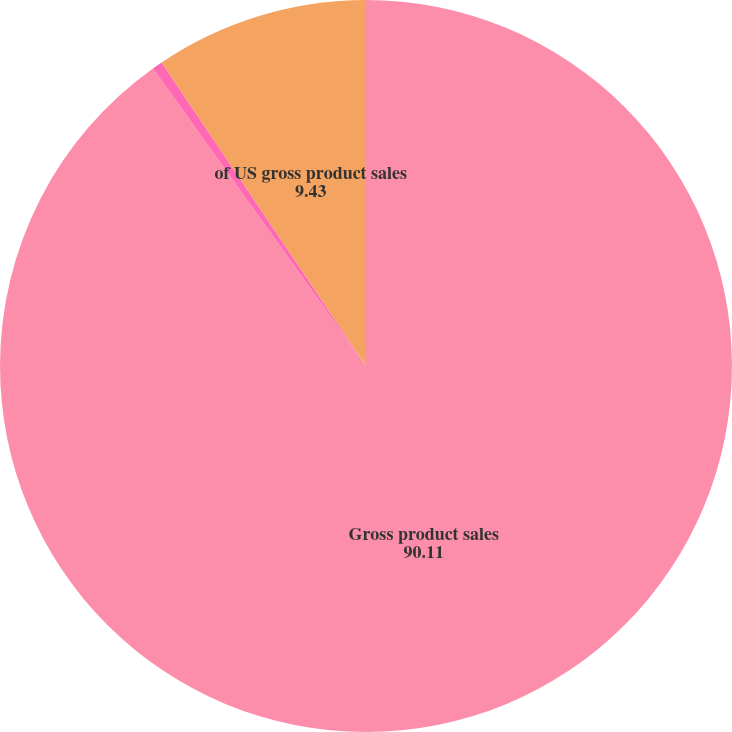Convert chart to OTSL. <chart><loc_0><loc_0><loc_500><loc_500><pie_chart><fcel>Gross product sales<fcel>of total gross revenues<fcel>of US gross product sales<nl><fcel>90.11%<fcel>0.46%<fcel>9.43%<nl></chart> 